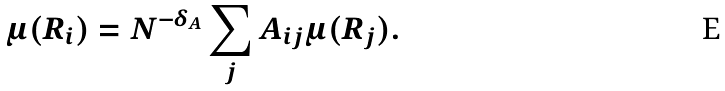Convert formula to latex. <formula><loc_0><loc_0><loc_500><loc_500>\mu ( R _ { i } ) = N ^ { - \delta _ { A } } \sum _ { j } A _ { i j } \mu ( R _ { j } ) .</formula> 